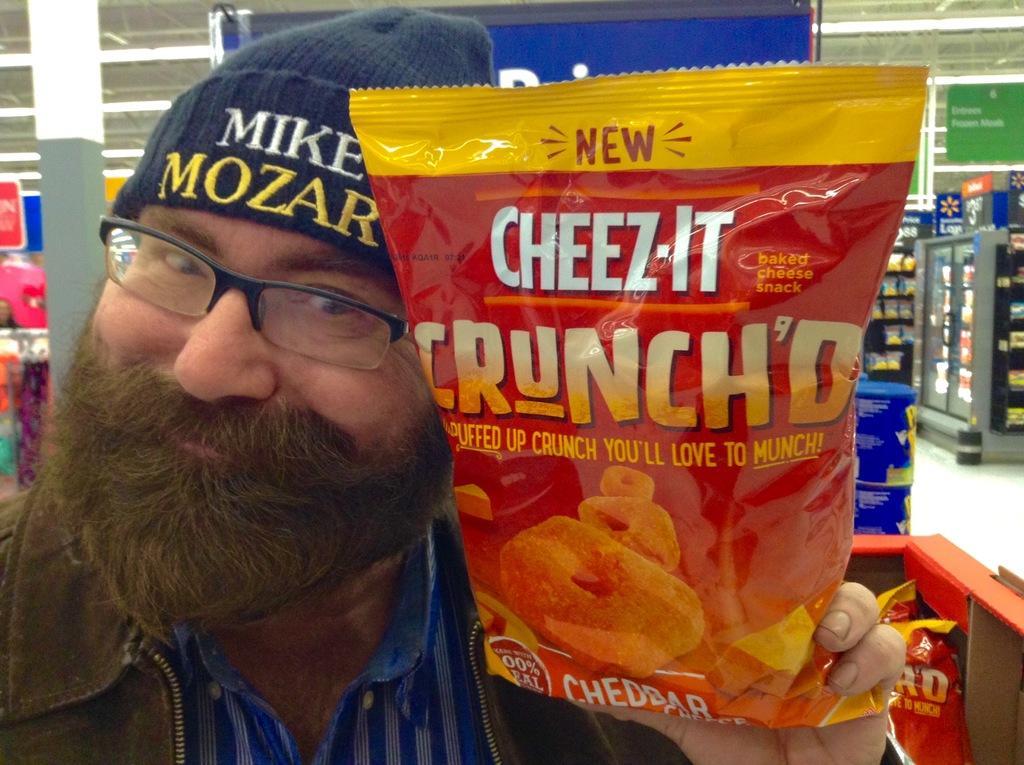Can you describe this image briefly? In this picture we can see a man with the spectacles and he is holding a food packet. Behind the man there are boards and some objects. 